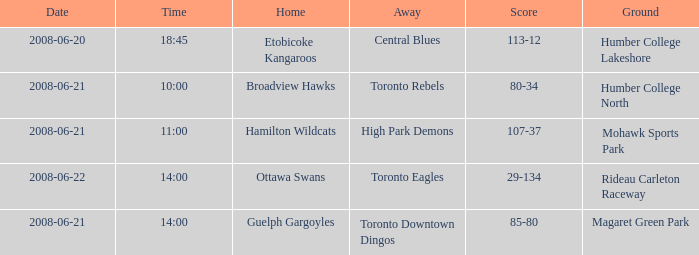Can you explain the "away with a ground" concept at humber college lakeshore campus? Central Blues. 